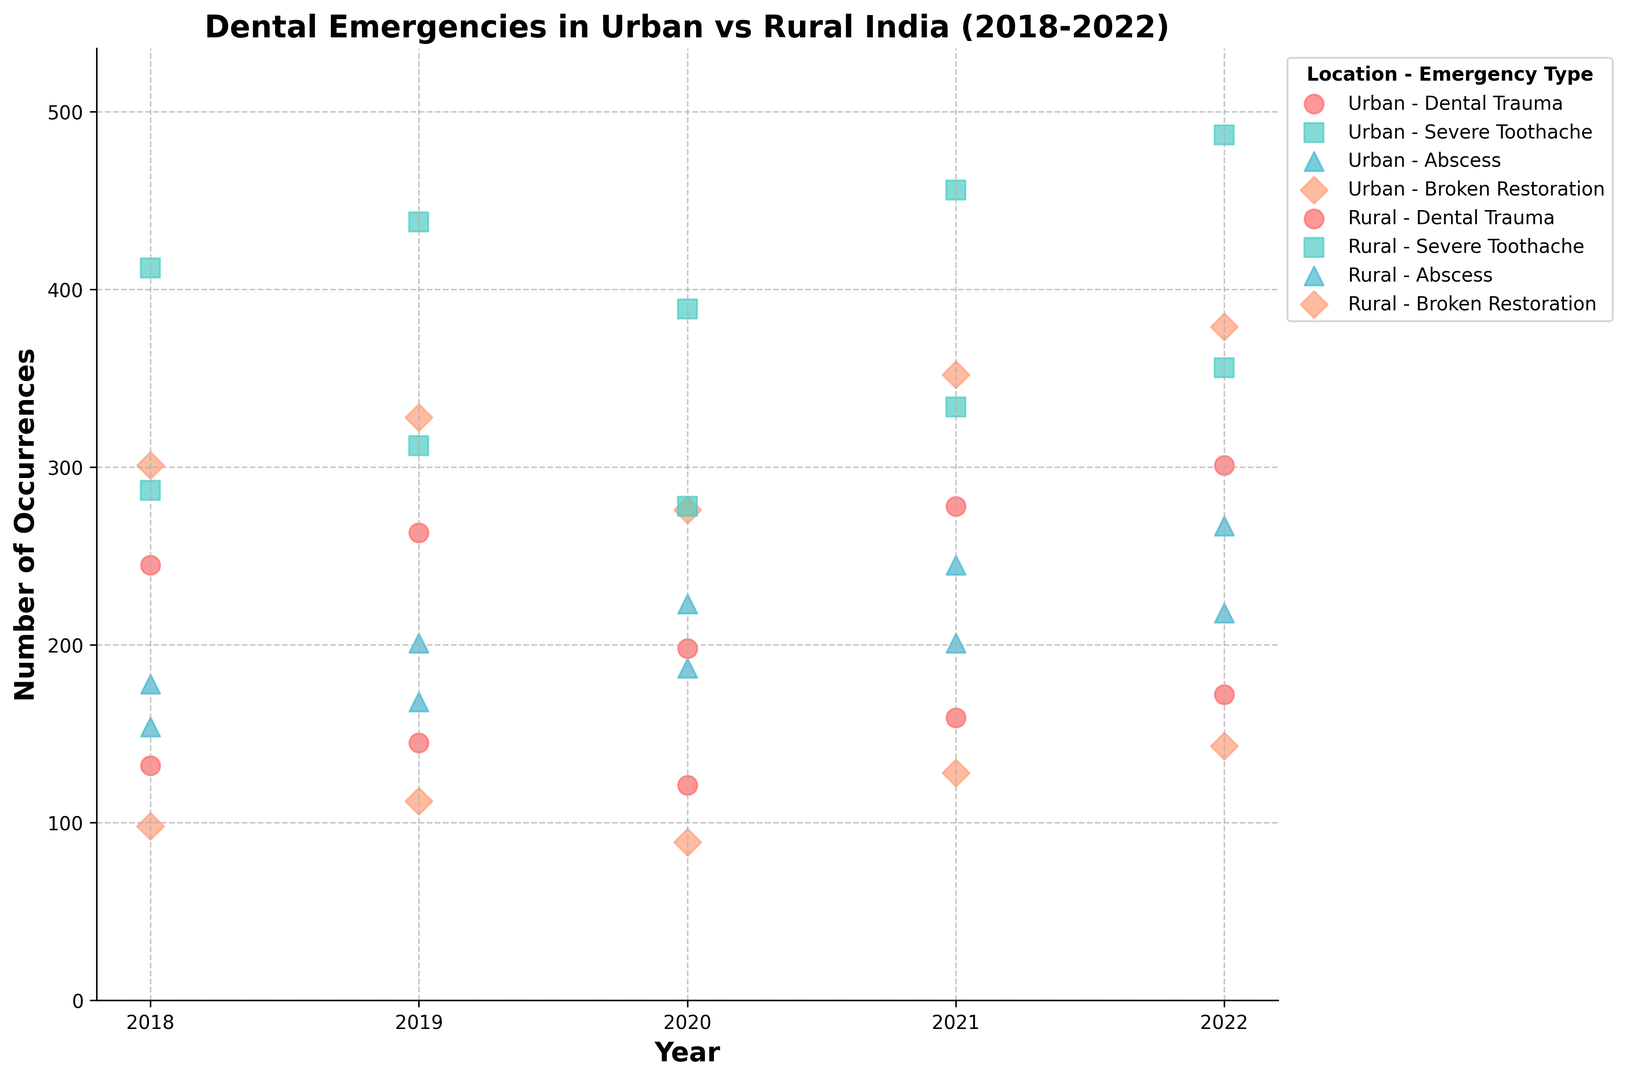What is the overall trend in the number of dental trauma cases in urban areas from 2018 to 2022? The figure shows an upward trend with the occurrences of dental trauma in urban areas increasing from 245 in 2018 to 301 in 2022. This is observed from the scattered data points for urban dental trauma, which generally point towards an increase year by year.
Answer: Increasing Which year has the highest reported cases of severe toothache in rural areas and how many cases were there? Looking at the scatter plot for severe toothache in rural areas, the highest data point is in the year 2022 with 356 occurrences. This can be determined by the position of the marker labeled as 'Rural - Severe Toothache' relative to the y-axis across the years.
Answer: 2022, 356 cases What is the difference in the number of abscess cases between urban and rural areas in 2020? The data points for abscess in 2020 are 223 occurrences in urban areas and 187 occurrences in rural areas. To find the difference, subtract the rural count from the urban count: 223 - 187 = 36.
Answer: 36 On average, how many cases of broken restoration are reported in rural areas each year from 2018 to 2022? For each year from 2018 to 2022, the rural occurrences of broken restoration are 98, 112, 89, 128, and 143, respectively. To find the average: (98 + 112 + 89 + 128 + 143) / 5 = 570 / 5 = 114.
Answer: 114 Compare the occurrences of dental trauma between urban and rural areas in 2019. Which area had more cases and by how much? In 2019, the occurrences of dental trauma in urban areas are 263 and in rural areas are 145. Urban areas had more cases. The difference is calculated as 263 - 145 = 118.
Answer: Urban, 118 more cases Which emergency type has the most occurrences in urban areas in 2021? By examining the scatter points for different emergency types in urban areas for 2021, 'Severe Toothache' has the highest position relative to the y-axis with 456 occurrences.
Answer: Severe Toothache How did the number of abscess cases change in rural areas from 2020 to 2022? The occurrences of abscess in rural areas were 187 in 2020, 201 in 2021, and 218 in 2022. The number increased each year: 187 to 201 from 2020 to 2021, and 201 to 218 from 2021 to 2022.
Answer: Increased Which emergency type experienced the least number of occurrences in urban areas in 2020 and how many were there? Referring to the scatter points for urban areas in 2020, 'Dental Trauma' has the lowest count with 198 occurrences.
Answer: Dental Trauma, 198 cases Are there any years where the number of severe toothache cases is the same in both urban and rural areas? By comparing the scatter points of severe toothache between urban and rural for all years, there are no years where the data points align vertically, indicating the same number of cases.
Answer: No From 2018 to 2022, which location and emergency type had the most fluctuations in occurrences? Observing the scatter plots, 'Severe Toothache' in urban areas shows the most fluctuation with occurrences ranging from 412 in 2018 to 487 in 2022, with notable changes every year.
Answer: Urban - Severe Toothache 